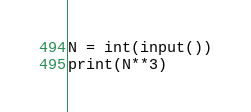<code> <loc_0><loc_0><loc_500><loc_500><_Python_>N = int(input())
print(N**3)</code> 